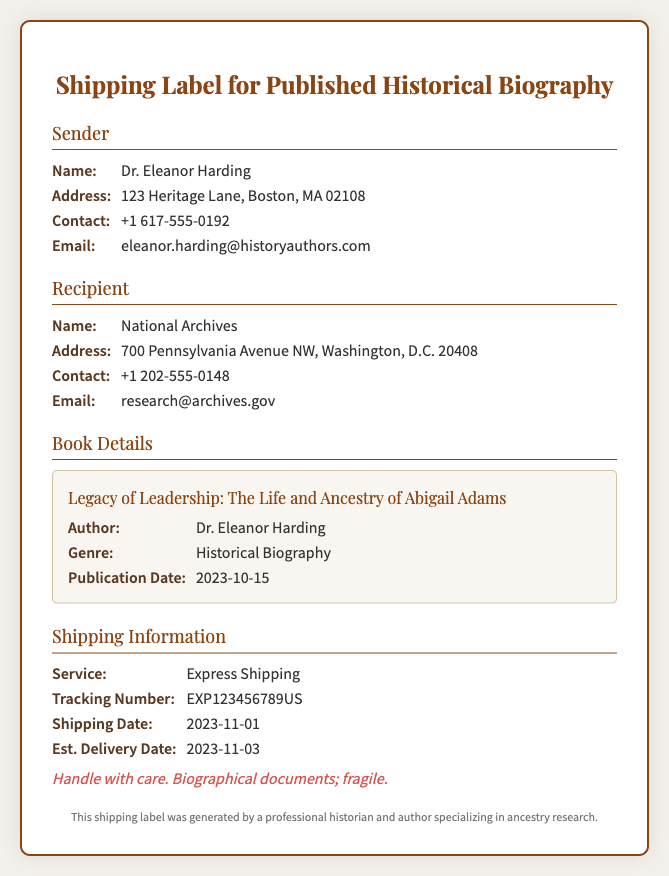What is the name of the sender? The sender's name is provided in the document under the "Sender" section.
Answer: Dr. Eleanor Harding What is the recipient's email address? The recipient's email address can be found in the "Recipient" section.
Answer: research@archives.gov When was the book published? The publication date is stated in the "Book Details" section.
Answer: 2023-10-15 What genre is the book? The genre is listed in the "Book Details" section of the document.
Answer: Historical Biography What is the tracking number for the shipment? The tracking number is specified in the "Shipping Information" section.
Answer: EXP123456789US What is the estimated delivery date? The estimated delivery date is mentioned in the "Shipping Information" section.
Answer: 2023-11-03 What kind of shipping service is used? The shipping service type is described in the "Shipping Information" section.
Answer: Express Shipping Who is the author of the book? The author's name is located in the "Book Details" section.
Answer: Dr. Eleanor Harding What is the primary instruction for handling the shipment? The handling instructions are provided at the end of the "Shipping Information" section.
Answer: Handle with care. Biographical documents; fragile 